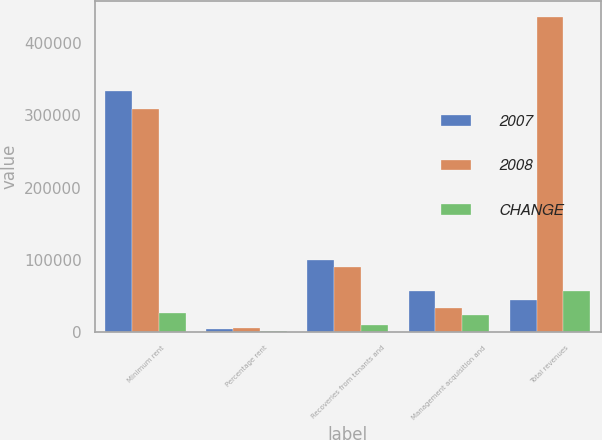Convert chart. <chart><loc_0><loc_0><loc_500><loc_500><stacked_bar_chart><ecel><fcel>Minimum rent<fcel>Percentage rent<fcel>Recoveries from tenants and<fcel>Management acquisition and<fcel>Total revenues<nl><fcel>2007<fcel>334332<fcel>4260<fcel>98797<fcel>56032<fcel>44548<nl><fcel>2008<fcel>308720<fcel>4661<fcel>90137<fcel>33064<fcel>436582<nl><fcel>CHANGE<fcel>25612<fcel>401<fcel>8660<fcel>22968<fcel>56839<nl></chart> 